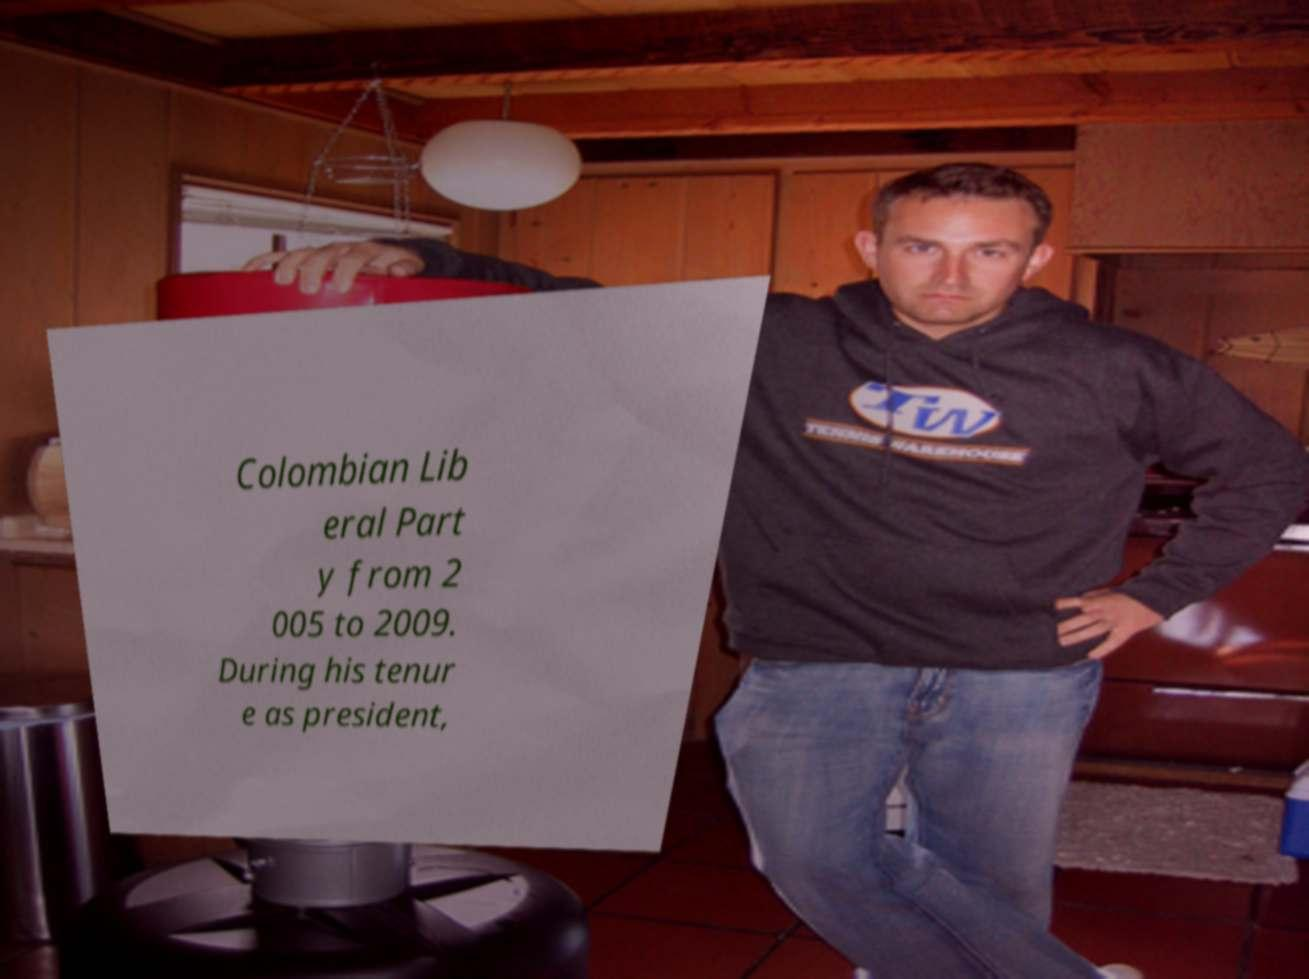Please identify and transcribe the text found in this image. Colombian Lib eral Part y from 2 005 to 2009. During his tenur e as president, 